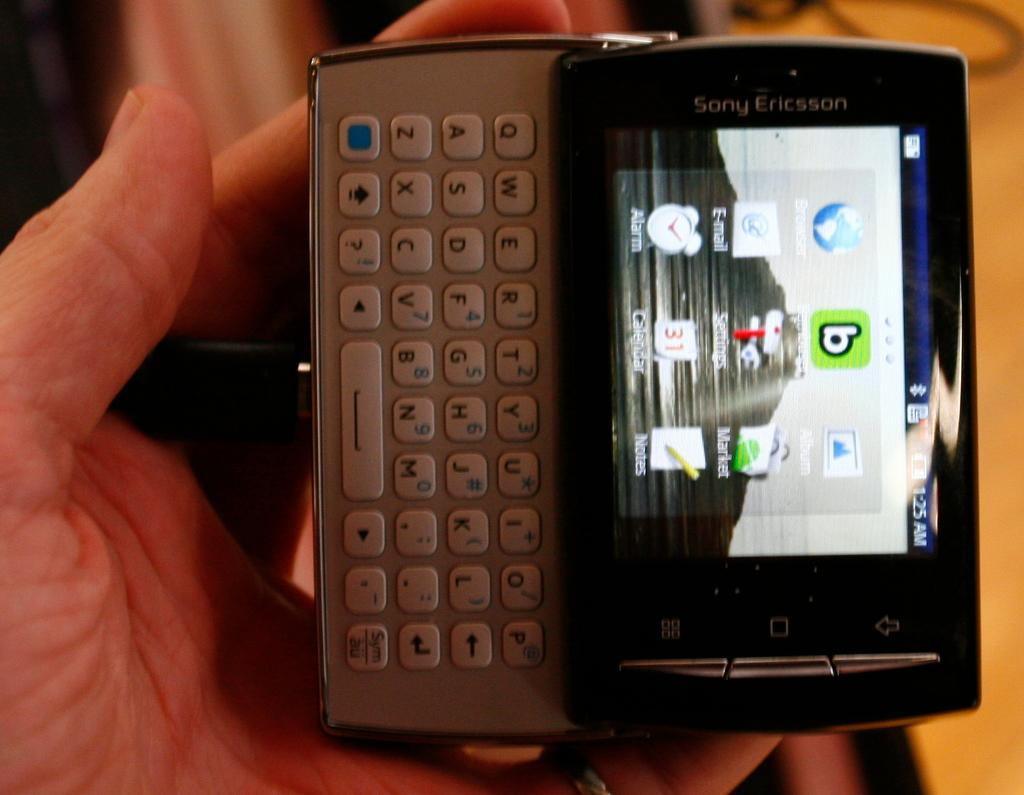<image>
Create a compact narrative representing the image presented. Sony Ericsson phone with keyboard is in a white person hand 